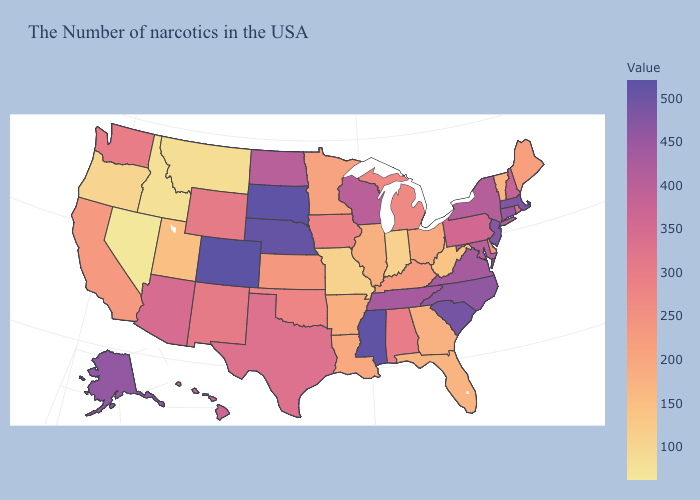Does Oklahoma have a lower value than Texas?
Answer briefly. Yes. Which states have the lowest value in the Northeast?
Concise answer only. Vermont. Does Colorado have the highest value in the USA?
Give a very brief answer. Yes. Which states have the lowest value in the Northeast?
Short answer required. Vermont. Does Colorado have the highest value in the USA?
Concise answer only. Yes. Among the states that border Utah , does New Mexico have the lowest value?
Give a very brief answer. No. Which states have the highest value in the USA?
Quick response, please. Colorado. 